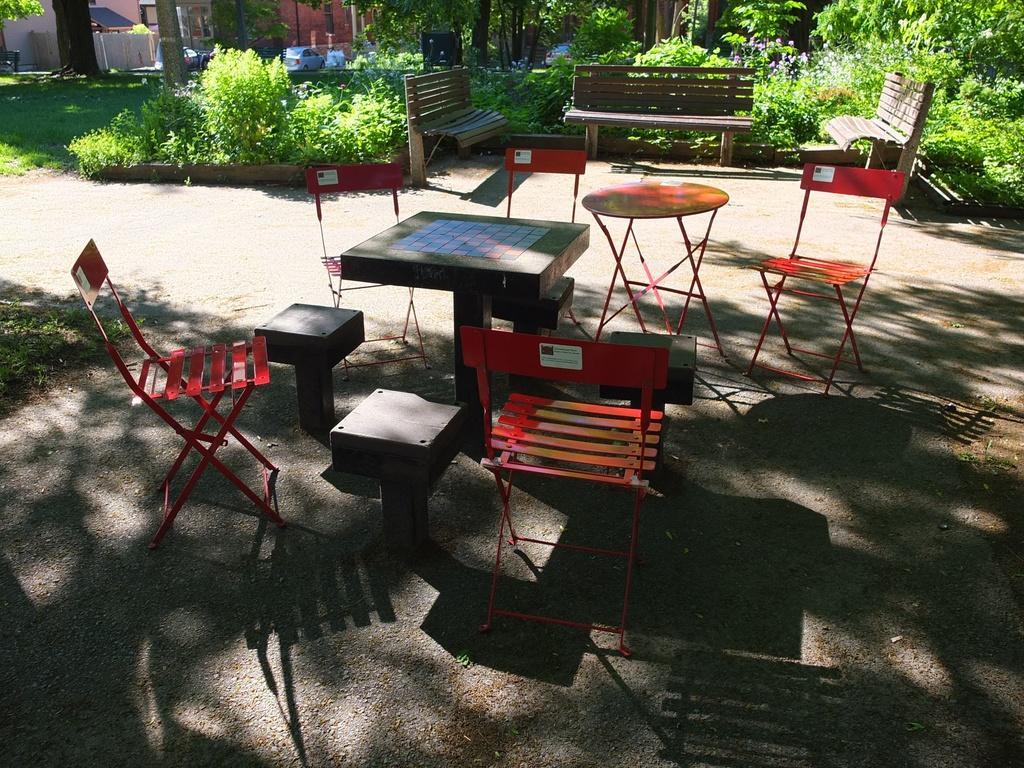Please provide a concise description of this image. In this image I can see few tables, few chairs, few benches, plants, shadows and in the background I can see grass. 